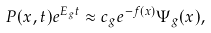Convert formula to latex. <formula><loc_0><loc_0><loc_500><loc_500>P ( x , t ) e ^ { E _ { g } t } \approx c _ { g } e ^ { - f ( x ) } \Psi _ { g } ( x ) ,</formula> 